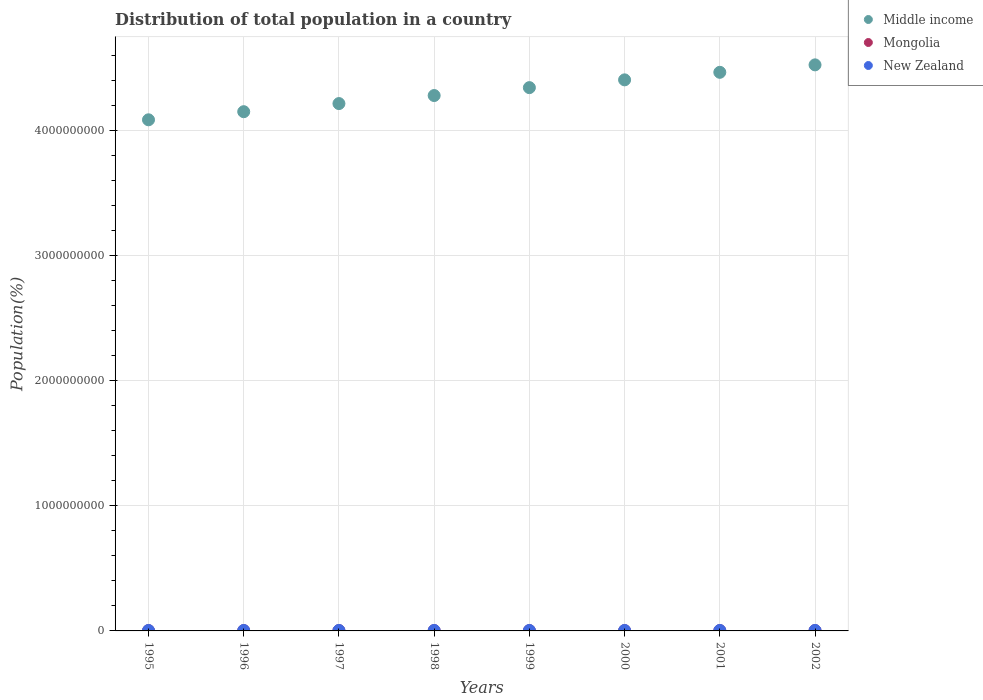What is the population of in New Zealand in 2001?
Offer a terse response. 3.88e+06. Across all years, what is the maximum population of in Middle income?
Provide a succinct answer. 4.53e+09. Across all years, what is the minimum population of in New Zealand?
Your answer should be compact. 3.67e+06. In which year was the population of in New Zealand maximum?
Your answer should be compact. 2002. What is the total population of in Mongolia in the graph?
Offer a terse response. 1.89e+07. What is the difference between the population of in New Zealand in 1995 and that in 1999?
Your answer should be compact. -1.62e+05. What is the difference between the population of in Middle income in 1995 and the population of in New Zealand in 2001?
Offer a terse response. 4.08e+09. What is the average population of in Middle income per year?
Provide a succinct answer. 4.31e+09. In the year 2002, what is the difference between the population of in New Zealand and population of in Middle income?
Give a very brief answer. -4.52e+09. In how many years, is the population of in Mongolia greater than 1400000000 %?
Ensure brevity in your answer.  0. What is the ratio of the population of in Mongolia in 1997 to that in 2001?
Make the answer very short. 0.97. What is the difference between the highest and the second highest population of in Mongolia?
Provide a succinct answer. 2.38e+04. What is the difference between the highest and the lowest population of in New Zealand?
Your response must be concise. 2.75e+05. In how many years, is the population of in Mongolia greater than the average population of in Mongolia taken over all years?
Offer a terse response. 4. Is the sum of the population of in Mongolia in 1999 and 2000 greater than the maximum population of in New Zealand across all years?
Offer a terse response. Yes. Is the population of in Middle income strictly greater than the population of in New Zealand over the years?
Give a very brief answer. Yes. What is the title of the graph?
Keep it short and to the point. Distribution of total population in a country. What is the label or title of the X-axis?
Your response must be concise. Years. What is the label or title of the Y-axis?
Provide a succinct answer. Population(%). What is the Population(%) of Middle income in 1995?
Give a very brief answer. 4.09e+09. What is the Population(%) in Mongolia in 1995?
Your answer should be very brief. 2.30e+06. What is the Population(%) of New Zealand in 1995?
Offer a very short reply. 3.67e+06. What is the Population(%) of Middle income in 1996?
Give a very brief answer. 4.15e+09. What is the Population(%) in Mongolia in 1996?
Your answer should be compact. 2.32e+06. What is the Population(%) in New Zealand in 1996?
Your answer should be very brief. 3.73e+06. What is the Population(%) of Middle income in 1997?
Your answer should be compact. 4.22e+09. What is the Population(%) of Mongolia in 1997?
Your answer should be compact. 2.34e+06. What is the Population(%) in New Zealand in 1997?
Your response must be concise. 3.78e+06. What is the Population(%) of Middle income in 1998?
Provide a short and direct response. 4.28e+09. What is the Population(%) in Mongolia in 1998?
Give a very brief answer. 2.36e+06. What is the Population(%) in New Zealand in 1998?
Make the answer very short. 3.82e+06. What is the Population(%) of Middle income in 1999?
Offer a very short reply. 4.34e+09. What is the Population(%) in Mongolia in 1999?
Offer a terse response. 2.38e+06. What is the Population(%) in New Zealand in 1999?
Ensure brevity in your answer.  3.84e+06. What is the Population(%) in Middle income in 2000?
Provide a succinct answer. 4.41e+09. What is the Population(%) of Mongolia in 2000?
Offer a terse response. 2.40e+06. What is the Population(%) in New Zealand in 2000?
Ensure brevity in your answer.  3.86e+06. What is the Population(%) of Middle income in 2001?
Your answer should be very brief. 4.47e+09. What is the Population(%) in Mongolia in 2001?
Your answer should be very brief. 2.42e+06. What is the Population(%) in New Zealand in 2001?
Give a very brief answer. 3.88e+06. What is the Population(%) in Middle income in 2002?
Offer a very short reply. 4.53e+09. What is the Population(%) in Mongolia in 2002?
Your answer should be compact. 2.44e+06. What is the Population(%) in New Zealand in 2002?
Offer a very short reply. 3.95e+06. Across all years, what is the maximum Population(%) of Middle income?
Ensure brevity in your answer.  4.53e+09. Across all years, what is the maximum Population(%) of Mongolia?
Keep it short and to the point. 2.44e+06. Across all years, what is the maximum Population(%) in New Zealand?
Provide a succinct answer. 3.95e+06. Across all years, what is the minimum Population(%) in Middle income?
Your answer should be compact. 4.09e+09. Across all years, what is the minimum Population(%) of Mongolia?
Give a very brief answer. 2.30e+06. Across all years, what is the minimum Population(%) in New Zealand?
Offer a terse response. 3.67e+06. What is the total Population(%) of Middle income in the graph?
Provide a succinct answer. 3.45e+1. What is the total Population(%) in Mongolia in the graph?
Ensure brevity in your answer.  1.89e+07. What is the total Population(%) of New Zealand in the graph?
Offer a terse response. 3.05e+07. What is the difference between the Population(%) of Middle income in 1995 and that in 1996?
Ensure brevity in your answer.  -6.48e+07. What is the difference between the Population(%) in Mongolia in 1995 and that in 1996?
Offer a very short reply. -1.85e+04. What is the difference between the Population(%) in New Zealand in 1995 and that in 1996?
Your answer should be compact. -5.86e+04. What is the difference between the Population(%) in Middle income in 1995 and that in 1997?
Your answer should be compact. -1.30e+08. What is the difference between the Population(%) in Mongolia in 1995 and that in 1997?
Provide a short and direct response. -3.77e+04. What is the difference between the Population(%) in New Zealand in 1995 and that in 1997?
Your answer should be compact. -1.08e+05. What is the difference between the Population(%) of Middle income in 1995 and that in 1998?
Ensure brevity in your answer.  -1.94e+08. What is the difference between the Population(%) of Mongolia in 1995 and that in 1998?
Ensure brevity in your answer.  -5.76e+04. What is the difference between the Population(%) of New Zealand in 1995 and that in 1998?
Keep it short and to the point. -1.42e+05. What is the difference between the Population(%) in Middle income in 1995 and that in 1999?
Your response must be concise. -2.57e+08. What is the difference between the Population(%) in Mongolia in 1995 and that in 1999?
Your answer should be compact. -7.81e+04. What is the difference between the Population(%) in New Zealand in 1995 and that in 1999?
Offer a terse response. -1.62e+05. What is the difference between the Population(%) of Middle income in 1995 and that in 2000?
Your answer should be very brief. -3.19e+08. What is the difference between the Population(%) of Mongolia in 1995 and that in 2000?
Provide a succinct answer. -9.94e+04. What is the difference between the Population(%) in New Zealand in 1995 and that in 2000?
Keep it short and to the point. -1.84e+05. What is the difference between the Population(%) of Middle income in 1995 and that in 2001?
Your answer should be very brief. -3.80e+08. What is the difference between the Population(%) of Mongolia in 1995 and that in 2001?
Offer a terse response. -1.22e+05. What is the difference between the Population(%) of New Zealand in 1995 and that in 2001?
Provide a succinct answer. -2.07e+05. What is the difference between the Population(%) in Middle income in 1995 and that in 2002?
Provide a short and direct response. -4.39e+08. What is the difference between the Population(%) of Mongolia in 1995 and that in 2002?
Your answer should be very brief. -1.45e+05. What is the difference between the Population(%) in New Zealand in 1995 and that in 2002?
Your answer should be very brief. -2.75e+05. What is the difference between the Population(%) of Middle income in 1996 and that in 1997?
Provide a short and direct response. -6.49e+07. What is the difference between the Population(%) in Mongolia in 1996 and that in 1997?
Offer a very short reply. -1.91e+04. What is the difference between the Population(%) in New Zealand in 1996 and that in 1997?
Offer a terse response. -4.93e+04. What is the difference between the Population(%) in Middle income in 1996 and that in 1998?
Provide a short and direct response. -1.29e+08. What is the difference between the Population(%) in Mongolia in 1996 and that in 1998?
Your answer should be compact. -3.90e+04. What is the difference between the Population(%) in New Zealand in 1996 and that in 1998?
Give a very brief answer. -8.30e+04. What is the difference between the Population(%) in Middle income in 1996 and that in 1999?
Keep it short and to the point. -1.92e+08. What is the difference between the Population(%) of Mongolia in 1996 and that in 1999?
Ensure brevity in your answer.  -5.96e+04. What is the difference between the Population(%) of New Zealand in 1996 and that in 1999?
Your answer should be compact. -1.03e+05. What is the difference between the Population(%) of Middle income in 1996 and that in 2000?
Provide a short and direct response. -2.55e+08. What is the difference between the Population(%) of Mongolia in 1996 and that in 2000?
Ensure brevity in your answer.  -8.09e+04. What is the difference between the Population(%) in New Zealand in 1996 and that in 2000?
Keep it short and to the point. -1.26e+05. What is the difference between the Population(%) of Middle income in 1996 and that in 2001?
Provide a short and direct response. -3.15e+08. What is the difference between the Population(%) of Mongolia in 1996 and that in 2001?
Your answer should be very brief. -1.03e+05. What is the difference between the Population(%) of New Zealand in 1996 and that in 2001?
Offer a very short reply. -1.48e+05. What is the difference between the Population(%) in Middle income in 1996 and that in 2002?
Ensure brevity in your answer.  -3.74e+08. What is the difference between the Population(%) of Mongolia in 1996 and that in 2002?
Provide a short and direct response. -1.27e+05. What is the difference between the Population(%) of New Zealand in 1996 and that in 2002?
Provide a succinct answer. -2.16e+05. What is the difference between the Population(%) of Middle income in 1997 and that in 1998?
Your answer should be very brief. -6.43e+07. What is the difference between the Population(%) in Mongolia in 1997 and that in 1998?
Your response must be concise. -1.99e+04. What is the difference between the Population(%) of New Zealand in 1997 and that in 1998?
Keep it short and to the point. -3.37e+04. What is the difference between the Population(%) of Middle income in 1997 and that in 1999?
Offer a very short reply. -1.27e+08. What is the difference between the Population(%) of Mongolia in 1997 and that in 1999?
Provide a short and direct response. -4.05e+04. What is the difference between the Population(%) of New Zealand in 1997 and that in 1999?
Give a very brief answer. -5.38e+04. What is the difference between the Population(%) in Middle income in 1997 and that in 2000?
Your answer should be compact. -1.90e+08. What is the difference between the Population(%) of Mongolia in 1997 and that in 2000?
Ensure brevity in your answer.  -6.17e+04. What is the difference between the Population(%) of New Zealand in 1997 and that in 2000?
Give a very brief answer. -7.64e+04. What is the difference between the Population(%) of Middle income in 1997 and that in 2001?
Keep it short and to the point. -2.50e+08. What is the difference between the Population(%) in Mongolia in 1997 and that in 2001?
Your answer should be compact. -8.40e+04. What is the difference between the Population(%) of New Zealand in 1997 and that in 2001?
Your answer should be very brief. -9.92e+04. What is the difference between the Population(%) in Middle income in 1997 and that in 2002?
Provide a succinct answer. -3.10e+08. What is the difference between the Population(%) of Mongolia in 1997 and that in 2002?
Give a very brief answer. -1.08e+05. What is the difference between the Population(%) in New Zealand in 1997 and that in 2002?
Make the answer very short. -1.67e+05. What is the difference between the Population(%) of Middle income in 1998 and that in 1999?
Your answer should be very brief. -6.32e+07. What is the difference between the Population(%) of Mongolia in 1998 and that in 1999?
Give a very brief answer. -2.06e+04. What is the difference between the Population(%) in New Zealand in 1998 and that in 1999?
Your answer should be compact. -2.01e+04. What is the difference between the Population(%) of Middle income in 1998 and that in 2000?
Your response must be concise. -1.25e+08. What is the difference between the Population(%) of Mongolia in 1998 and that in 2000?
Make the answer very short. -4.18e+04. What is the difference between the Population(%) of New Zealand in 1998 and that in 2000?
Your answer should be very brief. -4.27e+04. What is the difference between the Population(%) of Middle income in 1998 and that in 2001?
Provide a short and direct response. -1.86e+08. What is the difference between the Population(%) in Mongolia in 1998 and that in 2001?
Provide a short and direct response. -6.41e+04. What is the difference between the Population(%) of New Zealand in 1998 and that in 2001?
Provide a short and direct response. -6.55e+04. What is the difference between the Population(%) of Middle income in 1998 and that in 2002?
Give a very brief answer. -2.45e+08. What is the difference between the Population(%) of Mongolia in 1998 and that in 2002?
Your response must be concise. -8.79e+04. What is the difference between the Population(%) of New Zealand in 1998 and that in 2002?
Keep it short and to the point. -1.34e+05. What is the difference between the Population(%) in Middle income in 1999 and that in 2000?
Give a very brief answer. -6.21e+07. What is the difference between the Population(%) in Mongolia in 1999 and that in 2000?
Offer a terse response. -2.13e+04. What is the difference between the Population(%) in New Zealand in 1999 and that in 2000?
Provide a succinct answer. -2.26e+04. What is the difference between the Population(%) in Middle income in 1999 and that in 2001?
Provide a short and direct response. -1.22e+08. What is the difference between the Population(%) of Mongolia in 1999 and that in 2001?
Give a very brief answer. -4.36e+04. What is the difference between the Population(%) in New Zealand in 1999 and that in 2001?
Offer a very short reply. -4.54e+04. What is the difference between the Population(%) of Middle income in 1999 and that in 2002?
Keep it short and to the point. -1.82e+08. What is the difference between the Population(%) of Mongolia in 1999 and that in 2002?
Offer a very short reply. -6.73e+04. What is the difference between the Population(%) in New Zealand in 1999 and that in 2002?
Your answer should be compact. -1.13e+05. What is the difference between the Population(%) of Middle income in 2000 and that in 2001?
Offer a terse response. -6.03e+07. What is the difference between the Population(%) of Mongolia in 2000 and that in 2001?
Make the answer very short. -2.23e+04. What is the difference between the Population(%) in New Zealand in 2000 and that in 2001?
Provide a short and direct response. -2.28e+04. What is the difference between the Population(%) in Middle income in 2000 and that in 2002?
Your response must be concise. -1.20e+08. What is the difference between the Population(%) in Mongolia in 2000 and that in 2002?
Keep it short and to the point. -4.61e+04. What is the difference between the Population(%) in New Zealand in 2000 and that in 2002?
Provide a short and direct response. -9.08e+04. What is the difference between the Population(%) of Middle income in 2001 and that in 2002?
Your answer should be compact. -5.96e+07. What is the difference between the Population(%) of Mongolia in 2001 and that in 2002?
Your answer should be very brief. -2.38e+04. What is the difference between the Population(%) in New Zealand in 2001 and that in 2002?
Ensure brevity in your answer.  -6.80e+04. What is the difference between the Population(%) of Middle income in 1995 and the Population(%) of Mongolia in 1996?
Offer a very short reply. 4.08e+09. What is the difference between the Population(%) in Middle income in 1995 and the Population(%) in New Zealand in 1996?
Your answer should be compact. 4.08e+09. What is the difference between the Population(%) in Mongolia in 1995 and the Population(%) in New Zealand in 1996?
Ensure brevity in your answer.  -1.43e+06. What is the difference between the Population(%) in Middle income in 1995 and the Population(%) in Mongolia in 1997?
Give a very brief answer. 4.08e+09. What is the difference between the Population(%) of Middle income in 1995 and the Population(%) of New Zealand in 1997?
Your answer should be very brief. 4.08e+09. What is the difference between the Population(%) of Mongolia in 1995 and the Population(%) of New Zealand in 1997?
Keep it short and to the point. -1.48e+06. What is the difference between the Population(%) of Middle income in 1995 and the Population(%) of Mongolia in 1998?
Give a very brief answer. 4.08e+09. What is the difference between the Population(%) of Middle income in 1995 and the Population(%) of New Zealand in 1998?
Your answer should be compact. 4.08e+09. What is the difference between the Population(%) of Mongolia in 1995 and the Population(%) of New Zealand in 1998?
Offer a very short reply. -1.52e+06. What is the difference between the Population(%) of Middle income in 1995 and the Population(%) of Mongolia in 1999?
Offer a terse response. 4.08e+09. What is the difference between the Population(%) of Middle income in 1995 and the Population(%) of New Zealand in 1999?
Provide a succinct answer. 4.08e+09. What is the difference between the Population(%) of Mongolia in 1995 and the Population(%) of New Zealand in 1999?
Provide a short and direct response. -1.54e+06. What is the difference between the Population(%) of Middle income in 1995 and the Population(%) of Mongolia in 2000?
Provide a short and direct response. 4.08e+09. What is the difference between the Population(%) of Middle income in 1995 and the Population(%) of New Zealand in 2000?
Offer a very short reply. 4.08e+09. What is the difference between the Population(%) of Mongolia in 1995 and the Population(%) of New Zealand in 2000?
Keep it short and to the point. -1.56e+06. What is the difference between the Population(%) of Middle income in 1995 and the Population(%) of Mongolia in 2001?
Keep it short and to the point. 4.08e+09. What is the difference between the Population(%) in Middle income in 1995 and the Population(%) in New Zealand in 2001?
Offer a very short reply. 4.08e+09. What is the difference between the Population(%) of Mongolia in 1995 and the Population(%) of New Zealand in 2001?
Give a very brief answer. -1.58e+06. What is the difference between the Population(%) of Middle income in 1995 and the Population(%) of Mongolia in 2002?
Offer a very short reply. 4.08e+09. What is the difference between the Population(%) in Middle income in 1995 and the Population(%) in New Zealand in 2002?
Provide a short and direct response. 4.08e+09. What is the difference between the Population(%) in Mongolia in 1995 and the Population(%) in New Zealand in 2002?
Your answer should be compact. -1.65e+06. What is the difference between the Population(%) in Middle income in 1996 and the Population(%) in Mongolia in 1997?
Give a very brief answer. 4.15e+09. What is the difference between the Population(%) in Middle income in 1996 and the Population(%) in New Zealand in 1997?
Provide a succinct answer. 4.15e+09. What is the difference between the Population(%) in Mongolia in 1996 and the Population(%) in New Zealand in 1997?
Provide a short and direct response. -1.46e+06. What is the difference between the Population(%) of Middle income in 1996 and the Population(%) of Mongolia in 1998?
Keep it short and to the point. 4.15e+09. What is the difference between the Population(%) in Middle income in 1996 and the Population(%) in New Zealand in 1998?
Your answer should be compact. 4.15e+09. What is the difference between the Population(%) of Mongolia in 1996 and the Population(%) of New Zealand in 1998?
Provide a short and direct response. -1.50e+06. What is the difference between the Population(%) of Middle income in 1996 and the Population(%) of Mongolia in 1999?
Offer a very short reply. 4.15e+09. What is the difference between the Population(%) of Middle income in 1996 and the Population(%) of New Zealand in 1999?
Keep it short and to the point. 4.15e+09. What is the difference between the Population(%) of Mongolia in 1996 and the Population(%) of New Zealand in 1999?
Provide a succinct answer. -1.52e+06. What is the difference between the Population(%) in Middle income in 1996 and the Population(%) in Mongolia in 2000?
Provide a succinct answer. 4.15e+09. What is the difference between the Population(%) of Middle income in 1996 and the Population(%) of New Zealand in 2000?
Offer a terse response. 4.15e+09. What is the difference between the Population(%) in Mongolia in 1996 and the Population(%) in New Zealand in 2000?
Make the answer very short. -1.54e+06. What is the difference between the Population(%) in Middle income in 1996 and the Population(%) in Mongolia in 2001?
Offer a terse response. 4.15e+09. What is the difference between the Population(%) in Middle income in 1996 and the Population(%) in New Zealand in 2001?
Provide a succinct answer. 4.15e+09. What is the difference between the Population(%) of Mongolia in 1996 and the Population(%) of New Zealand in 2001?
Ensure brevity in your answer.  -1.56e+06. What is the difference between the Population(%) in Middle income in 1996 and the Population(%) in Mongolia in 2002?
Keep it short and to the point. 4.15e+09. What is the difference between the Population(%) in Middle income in 1996 and the Population(%) in New Zealand in 2002?
Give a very brief answer. 4.15e+09. What is the difference between the Population(%) of Mongolia in 1996 and the Population(%) of New Zealand in 2002?
Keep it short and to the point. -1.63e+06. What is the difference between the Population(%) in Middle income in 1997 and the Population(%) in Mongolia in 1998?
Keep it short and to the point. 4.21e+09. What is the difference between the Population(%) in Middle income in 1997 and the Population(%) in New Zealand in 1998?
Your answer should be compact. 4.21e+09. What is the difference between the Population(%) in Mongolia in 1997 and the Population(%) in New Zealand in 1998?
Ensure brevity in your answer.  -1.48e+06. What is the difference between the Population(%) of Middle income in 1997 and the Population(%) of Mongolia in 1999?
Your answer should be compact. 4.21e+09. What is the difference between the Population(%) of Middle income in 1997 and the Population(%) of New Zealand in 1999?
Your answer should be compact. 4.21e+09. What is the difference between the Population(%) in Mongolia in 1997 and the Population(%) in New Zealand in 1999?
Keep it short and to the point. -1.50e+06. What is the difference between the Population(%) in Middle income in 1997 and the Population(%) in Mongolia in 2000?
Your answer should be very brief. 4.21e+09. What is the difference between the Population(%) of Middle income in 1997 and the Population(%) of New Zealand in 2000?
Make the answer very short. 4.21e+09. What is the difference between the Population(%) of Mongolia in 1997 and the Population(%) of New Zealand in 2000?
Offer a very short reply. -1.52e+06. What is the difference between the Population(%) of Middle income in 1997 and the Population(%) of Mongolia in 2001?
Make the answer very short. 4.21e+09. What is the difference between the Population(%) in Middle income in 1997 and the Population(%) in New Zealand in 2001?
Ensure brevity in your answer.  4.21e+09. What is the difference between the Population(%) of Mongolia in 1997 and the Population(%) of New Zealand in 2001?
Keep it short and to the point. -1.54e+06. What is the difference between the Population(%) in Middle income in 1997 and the Population(%) in Mongolia in 2002?
Keep it short and to the point. 4.21e+09. What is the difference between the Population(%) in Middle income in 1997 and the Population(%) in New Zealand in 2002?
Ensure brevity in your answer.  4.21e+09. What is the difference between the Population(%) in Mongolia in 1997 and the Population(%) in New Zealand in 2002?
Offer a terse response. -1.61e+06. What is the difference between the Population(%) in Middle income in 1998 and the Population(%) in Mongolia in 1999?
Offer a very short reply. 4.28e+09. What is the difference between the Population(%) of Middle income in 1998 and the Population(%) of New Zealand in 1999?
Your answer should be compact. 4.28e+09. What is the difference between the Population(%) of Mongolia in 1998 and the Population(%) of New Zealand in 1999?
Give a very brief answer. -1.48e+06. What is the difference between the Population(%) of Middle income in 1998 and the Population(%) of Mongolia in 2000?
Offer a terse response. 4.28e+09. What is the difference between the Population(%) in Middle income in 1998 and the Population(%) in New Zealand in 2000?
Keep it short and to the point. 4.28e+09. What is the difference between the Population(%) in Mongolia in 1998 and the Population(%) in New Zealand in 2000?
Your answer should be very brief. -1.50e+06. What is the difference between the Population(%) in Middle income in 1998 and the Population(%) in Mongolia in 2001?
Your response must be concise. 4.28e+09. What is the difference between the Population(%) in Middle income in 1998 and the Population(%) in New Zealand in 2001?
Your response must be concise. 4.28e+09. What is the difference between the Population(%) in Mongolia in 1998 and the Population(%) in New Zealand in 2001?
Give a very brief answer. -1.52e+06. What is the difference between the Population(%) of Middle income in 1998 and the Population(%) of Mongolia in 2002?
Your answer should be very brief. 4.28e+09. What is the difference between the Population(%) in Middle income in 1998 and the Population(%) in New Zealand in 2002?
Your response must be concise. 4.28e+09. What is the difference between the Population(%) of Mongolia in 1998 and the Population(%) of New Zealand in 2002?
Your answer should be very brief. -1.59e+06. What is the difference between the Population(%) of Middle income in 1999 and the Population(%) of Mongolia in 2000?
Provide a succinct answer. 4.34e+09. What is the difference between the Population(%) in Middle income in 1999 and the Population(%) in New Zealand in 2000?
Give a very brief answer. 4.34e+09. What is the difference between the Population(%) of Mongolia in 1999 and the Population(%) of New Zealand in 2000?
Offer a very short reply. -1.48e+06. What is the difference between the Population(%) in Middle income in 1999 and the Population(%) in Mongolia in 2001?
Offer a very short reply. 4.34e+09. What is the difference between the Population(%) in Middle income in 1999 and the Population(%) in New Zealand in 2001?
Your answer should be very brief. 4.34e+09. What is the difference between the Population(%) of Mongolia in 1999 and the Population(%) of New Zealand in 2001?
Provide a succinct answer. -1.50e+06. What is the difference between the Population(%) in Middle income in 1999 and the Population(%) in Mongolia in 2002?
Ensure brevity in your answer.  4.34e+09. What is the difference between the Population(%) of Middle income in 1999 and the Population(%) of New Zealand in 2002?
Provide a succinct answer. 4.34e+09. What is the difference between the Population(%) in Mongolia in 1999 and the Population(%) in New Zealand in 2002?
Your answer should be very brief. -1.57e+06. What is the difference between the Population(%) in Middle income in 2000 and the Population(%) in Mongolia in 2001?
Offer a very short reply. 4.40e+09. What is the difference between the Population(%) in Middle income in 2000 and the Population(%) in New Zealand in 2001?
Provide a succinct answer. 4.40e+09. What is the difference between the Population(%) in Mongolia in 2000 and the Population(%) in New Zealand in 2001?
Make the answer very short. -1.48e+06. What is the difference between the Population(%) in Middle income in 2000 and the Population(%) in Mongolia in 2002?
Ensure brevity in your answer.  4.40e+09. What is the difference between the Population(%) of Middle income in 2000 and the Population(%) of New Zealand in 2002?
Make the answer very short. 4.40e+09. What is the difference between the Population(%) in Mongolia in 2000 and the Population(%) in New Zealand in 2002?
Your answer should be very brief. -1.55e+06. What is the difference between the Population(%) in Middle income in 2001 and the Population(%) in Mongolia in 2002?
Make the answer very short. 4.46e+09. What is the difference between the Population(%) in Middle income in 2001 and the Population(%) in New Zealand in 2002?
Provide a succinct answer. 4.46e+09. What is the difference between the Population(%) of Mongolia in 2001 and the Population(%) of New Zealand in 2002?
Make the answer very short. -1.53e+06. What is the average Population(%) of Middle income per year?
Your answer should be very brief. 4.31e+09. What is the average Population(%) of Mongolia per year?
Offer a terse response. 2.37e+06. What is the average Population(%) of New Zealand per year?
Your answer should be compact. 3.82e+06. In the year 1995, what is the difference between the Population(%) of Middle income and Population(%) of Mongolia?
Make the answer very short. 4.08e+09. In the year 1995, what is the difference between the Population(%) in Middle income and Population(%) in New Zealand?
Provide a short and direct response. 4.08e+09. In the year 1995, what is the difference between the Population(%) of Mongolia and Population(%) of New Zealand?
Provide a short and direct response. -1.38e+06. In the year 1996, what is the difference between the Population(%) in Middle income and Population(%) in Mongolia?
Ensure brevity in your answer.  4.15e+09. In the year 1996, what is the difference between the Population(%) in Middle income and Population(%) in New Zealand?
Keep it short and to the point. 4.15e+09. In the year 1996, what is the difference between the Population(%) in Mongolia and Population(%) in New Zealand?
Provide a succinct answer. -1.42e+06. In the year 1997, what is the difference between the Population(%) of Middle income and Population(%) of Mongolia?
Provide a succinct answer. 4.21e+09. In the year 1997, what is the difference between the Population(%) of Middle income and Population(%) of New Zealand?
Ensure brevity in your answer.  4.21e+09. In the year 1997, what is the difference between the Population(%) of Mongolia and Population(%) of New Zealand?
Your answer should be very brief. -1.45e+06. In the year 1998, what is the difference between the Population(%) of Middle income and Population(%) of Mongolia?
Offer a very short reply. 4.28e+09. In the year 1998, what is the difference between the Population(%) in Middle income and Population(%) in New Zealand?
Ensure brevity in your answer.  4.28e+09. In the year 1998, what is the difference between the Population(%) in Mongolia and Population(%) in New Zealand?
Provide a short and direct response. -1.46e+06. In the year 1999, what is the difference between the Population(%) of Middle income and Population(%) of Mongolia?
Your answer should be compact. 4.34e+09. In the year 1999, what is the difference between the Population(%) in Middle income and Population(%) in New Zealand?
Offer a terse response. 4.34e+09. In the year 1999, what is the difference between the Population(%) in Mongolia and Population(%) in New Zealand?
Offer a terse response. -1.46e+06. In the year 2000, what is the difference between the Population(%) of Middle income and Population(%) of Mongolia?
Make the answer very short. 4.40e+09. In the year 2000, what is the difference between the Population(%) in Middle income and Population(%) in New Zealand?
Offer a very short reply. 4.40e+09. In the year 2000, what is the difference between the Population(%) of Mongolia and Population(%) of New Zealand?
Give a very brief answer. -1.46e+06. In the year 2001, what is the difference between the Population(%) in Middle income and Population(%) in Mongolia?
Your answer should be compact. 4.46e+09. In the year 2001, what is the difference between the Population(%) of Middle income and Population(%) of New Zealand?
Provide a succinct answer. 4.46e+09. In the year 2001, what is the difference between the Population(%) in Mongolia and Population(%) in New Zealand?
Make the answer very short. -1.46e+06. In the year 2002, what is the difference between the Population(%) of Middle income and Population(%) of Mongolia?
Give a very brief answer. 4.52e+09. In the year 2002, what is the difference between the Population(%) of Middle income and Population(%) of New Zealand?
Make the answer very short. 4.52e+09. In the year 2002, what is the difference between the Population(%) in Mongolia and Population(%) in New Zealand?
Keep it short and to the point. -1.50e+06. What is the ratio of the Population(%) of Middle income in 1995 to that in 1996?
Give a very brief answer. 0.98. What is the ratio of the Population(%) in New Zealand in 1995 to that in 1996?
Your answer should be very brief. 0.98. What is the ratio of the Population(%) in Middle income in 1995 to that in 1997?
Give a very brief answer. 0.97. What is the ratio of the Population(%) of Mongolia in 1995 to that in 1997?
Your answer should be compact. 0.98. What is the ratio of the Population(%) in New Zealand in 1995 to that in 1997?
Offer a terse response. 0.97. What is the ratio of the Population(%) in Middle income in 1995 to that in 1998?
Offer a very short reply. 0.95. What is the ratio of the Population(%) in Mongolia in 1995 to that in 1998?
Your response must be concise. 0.98. What is the ratio of the Population(%) of New Zealand in 1995 to that in 1998?
Provide a short and direct response. 0.96. What is the ratio of the Population(%) in Middle income in 1995 to that in 1999?
Offer a very short reply. 0.94. What is the ratio of the Population(%) of Mongolia in 1995 to that in 1999?
Ensure brevity in your answer.  0.97. What is the ratio of the Population(%) of New Zealand in 1995 to that in 1999?
Offer a terse response. 0.96. What is the ratio of the Population(%) of Middle income in 1995 to that in 2000?
Offer a very short reply. 0.93. What is the ratio of the Population(%) in Mongolia in 1995 to that in 2000?
Provide a short and direct response. 0.96. What is the ratio of the Population(%) of New Zealand in 1995 to that in 2000?
Ensure brevity in your answer.  0.95. What is the ratio of the Population(%) in Middle income in 1995 to that in 2001?
Make the answer very short. 0.92. What is the ratio of the Population(%) in Mongolia in 1995 to that in 2001?
Your response must be concise. 0.95. What is the ratio of the Population(%) of New Zealand in 1995 to that in 2001?
Keep it short and to the point. 0.95. What is the ratio of the Population(%) in Middle income in 1995 to that in 2002?
Your answer should be compact. 0.9. What is the ratio of the Population(%) of Mongolia in 1995 to that in 2002?
Your response must be concise. 0.94. What is the ratio of the Population(%) of New Zealand in 1995 to that in 2002?
Keep it short and to the point. 0.93. What is the ratio of the Population(%) in Middle income in 1996 to that in 1997?
Keep it short and to the point. 0.98. What is the ratio of the Population(%) in Mongolia in 1996 to that in 1997?
Give a very brief answer. 0.99. What is the ratio of the Population(%) of Middle income in 1996 to that in 1998?
Offer a terse response. 0.97. What is the ratio of the Population(%) of Mongolia in 1996 to that in 1998?
Make the answer very short. 0.98. What is the ratio of the Population(%) of New Zealand in 1996 to that in 1998?
Make the answer very short. 0.98. What is the ratio of the Population(%) of Middle income in 1996 to that in 1999?
Your response must be concise. 0.96. What is the ratio of the Population(%) of Mongolia in 1996 to that in 1999?
Give a very brief answer. 0.97. What is the ratio of the Population(%) in New Zealand in 1996 to that in 1999?
Ensure brevity in your answer.  0.97. What is the ratio of the Population(%) in Middle income in 1996 to that in 2000?
Ensure brevity in your answer.  0.94. What is the ratio of the Population(%) of Mongolia in 1996 to that in 2000?
Your answer should be compact. 0.97. What is the ratio of the Population(%) in New Zealand in 1996 to that in 2000?
Your answer should be compact. 0.97. What is the ratio of the Population(%) in Middle income in 1996 to that in 2001?
Keep it short and to the point. 0.93. What is the ratio of the Population(%) of Mongolia in 1996 to that in 2001?
Provide a short and direct response. 0.96. What is the ratio of the Population(%) in New Zealand in 1996 to that in 2001?
Offer a very short reply. 0.96. What is the ratio of the Population(%) in Middle income in 1996 to that in 2002?
Keep it short and to the point. 0.92. What is the ratio of the Population(%) of Mongolia in 1996 to that in 2002?
Your answer should be very brief. 0.95. What is the ratio of the Population(%) in New Zealand in 1996 to that in 2002?
Make the answer very short. 0.95. What is the ratio of the Population(%) of Middle income in 1997 to that in 1998?
Make the answer very short. 0.98. What is the ratio of the Population(%) of Mongolia in 1997 to that in 1998?
Give a very brief answer. 0.99. What is the ratio of the Population(%) in New Zealand in 1997 to that in 1998?
Keep it short and to the point. 0.99. What is the ratio of the Population(%) in Middle income in 1997 to that in 1999?
Your response must be concise. 0.97. What is the ratio of the Population(%) in Mongolia in 1997 to that in 1999?
Provide a succinct answer. 0.98. What is the ratio of the Population(%) of Middle income in 1997 to that in 2000?
Your answer should be compact. 0.96. What is the ratio of the Population(%) in Mongolia in 1997 to that in 2000?
Your answer should be very brief. 0.97. What is the ratio of the Population(%) of New Zealand in 1997 to that in 2000?
Make the answer very short. 0.98. What is the ratio of the Population(%) of Middle income in 1997 to that in 2001?
Give a very brief answer. 0.94. What is the ratio of the Population(%) in Mongolia in 1997 to that in 2001?
Make the answer very short. 0.97. What is the ratio of the Population(%) of New Zealand in 1997 to that in 2001?
Provide a short and direct response. 0.97. What is the ratio of the Population(%) in Middle income in 1997 to that in 2002?
Provide a short and direct response. 0.93. What is the ratio of the Population(%) in Mongolia in 1997 to that in 2002?
Provide a short and direct response. 0.96. What is the ratio of the Population(%) in New Zealand in 1997 to that in 2002?
Offer a very short reply. 0.96. What is the ratio of the Population(%) in Middle income in 1998 to that in 1999?
Ensure brevity in your answer.  0.99. What is the ratio of the Population(%) of Mongolia in 1998 to that in 1999?
Provide a short and direct response. 0.99. What is the ratio of the Population(%) of New Zealand in 1998 to that in 1999?
Offer a very short reply. 0.99. What is the ratio of the Population(%) in Middle income in 1998 to that in 2000?
Give a very brief answer. 0.97. What is the ratio of the Population(%) in Mongolia in 1998 to that in 2000?
Provide a short and direct response. 0.98. What is the ratio of the Population(%) of New Zealand in 1998 to that in 2000?
Your response must be concise. 0.99. What is the ratio of the Population(%) in Middle income in 1998 to that in 2001?
Keep it short and to the point. 0.96. What is the ratio of the Population(%) in Mongolia in 1998 to that in 2001?
Your answer should be very brief. 0.97. What is the ratio of the Population(%) of New Zealand in 1998 to that in 2001?
Offer a very short reply. 0.98. What is the ratio of the Population(%) in Middle income in 1998 to that in 2002?
Your response must be concise. 0.95. What is the ratio of the Population(%) in New Zealand in 1998 to that in 2002?
Offer a terse response. 0.97. What is the ratio of the Population(%) of Middle income in 1999 to that in 2000?
Your answer should be very brief. 0.99. What is the ratio of the Population(%) of New Zealand in 1999 to that in 2000?
Provide a short and direct response. 0.99. What is the ratio of the Population(%) in Middle income in 1999 to that in 2001?
Offer a very short reply. 0.97. What is the ratio of the Population(%) of New Zealand in 1999 to that in 2001?
Provide a succinct answer. 0.99. What is the ratio of the Population(%) of Middle income in 1999 to that in 2002?
Ensure brevity in your answer.  0.96. What is the ratio of the Population(%) of Mongolia in 1999 to that in 2002?
Ensure brevity in your answer.  0.97. What is the ratio of the Population(%) in New Zealand in 1999 to that in 2002?
Give a very brief answer. 0.97. What is the ratio of the Population(%) in Middle income in 2000 to that in 2001?
Your response must be concise. 0.99. What is the ratio of the Population(%) of Mongolia in 2000 to that in 2001?
Provide a succinct answer. 0.99. What is the ratio of the Population(%) of New Zealand in 2000 to that in 2001?
Make the answer very short. 0.99. What is the ratio of the Population(%) of Middle income in 2000 to that in 2002?
Provide a succinct answer. 0.97. What is the ratio of the Population(%) in Mongolia in 2000 to that in 2002?
Your answer should be very brief. 0.98. What is the ratio of the Population(%) of Middle income in 2001 to that in 2002?
Your answer should be compact. 0.99. What is the ratio of the Population(%) of Mongolia in 2001 to that in 2002?
Offer a very short reply. 0.99. What is the ratio of the Population(%) in New Zealand in 2001 to that in 2002?
Make the answer very short. 0.98. What is the difference between the highest and the second highest Population(%) of Middle income?
Make the answer very short. 5.96e+07. What is the difference between the highest and the second highest Population(%) of Mongolia?
Your response must be concise. 2.38e+04. What is the difference between the highest and the second highest Population(%) of New Zealand?
Your response must be concise. 6.80e+04. What is the difference between the highest and the lowest Population(%) in Middle income?
Offer a very short reply. 4.39e+08. What is the difference between the highest and the lowest Population(%) of Mongolia?
Your response must be concise. 1.45e+05. What is the difference between the highest and the lowest Population(%) of New Zealand?
Ensure brevity in your answer.  2.75e+05. 